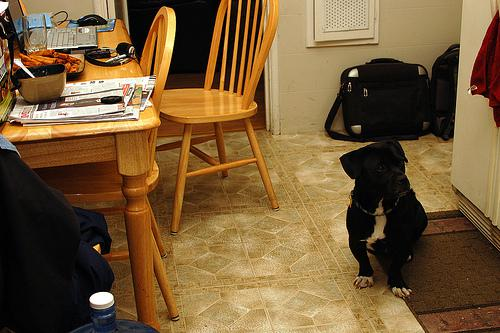Question: where is the laptop?
Choices:
A. At school.
B. At the store.
C. On the table.
D. In my desk.
Answer with the letter. Answer: C Question: what color is the bag leaning against the wall?
Choices:
A. Black.
B. Brown.
C. Yellow.
D. Green.
Answer with the letter. Answer: A Question: where is the brown rug?
Choices:
A. In my room.
B. In my kitchen.
C. In my den.
D. On the floor in front of the refrigerator.
Answer with the letter. Answer: D Question: what animal is sitting on the floor?
Choices:
A. A dog.
B. A cat.
C. A bear.
D. A deer.
Answer with the letter. Answer: A Question: where is the red towel in the picture?
Choices:
A. Hanging on the refrigerator.
B. Hanging in the bathroom.
C. On the sand at the beach.
D. Around my shoulders.
Answer with the letter. Answer: A Question: what in the picture is wearing a chain?
Choices:
A. The dog.
B. Me.
C. My mom.
D. My sister.
Answer with the letter. Answer: A 